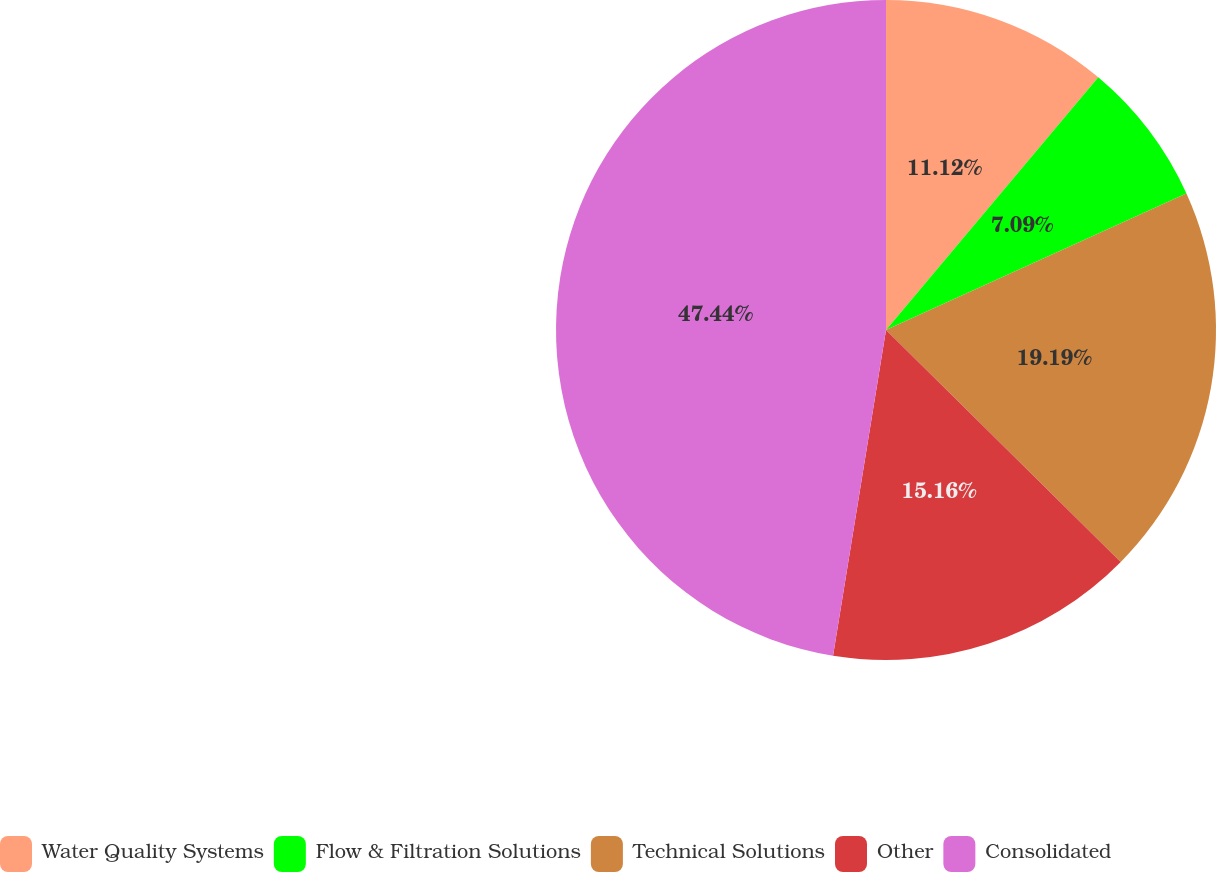<chart> <loc_0><loc_0><loc_500><loc_500><pie_chart><fcel>Water Quality Systems<fcel>Flow & Filtration Solutions<fcel>Technical Solutions<fcel>Other<fcel>Consolidated<nl><fcel>11.12%<fcel>7.09%<fcel>19.19%<fcel>15.16%<fcel>47.43%<nl></chart> 